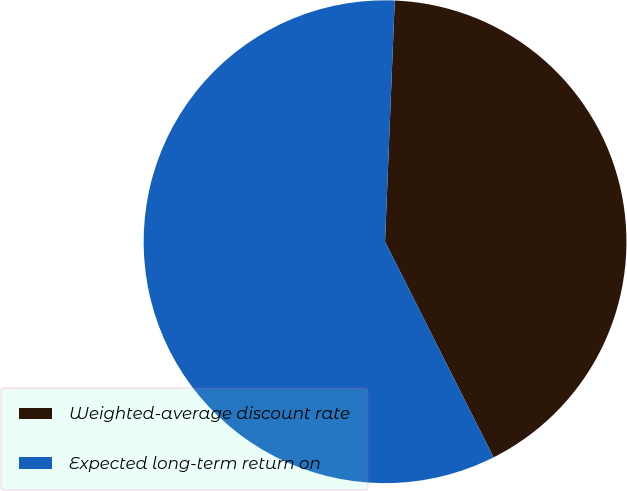Convert chart. <chart><loc_0><loc_0><loc_500><loc_500><pie_chart><fcel>Weighted-average discount rate<fcel>Expected long-term return on<nl><fcel>41.94%<fcel>58.06%<nl></chart> 